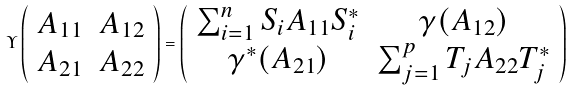Convert formula to latex. <formula><loc_0><loc_0><loc_500><loc_500>\Upsilon \left ( \begin{array} { c c } A _ { 1 1 } & A _ { 1 2 } \\ A _ { 2 1 } & A _ { 2 2 } \end{array} \right ) = \left ( \begin{array} { c c } \sum _ { i = 1 } ^ { n } S _ { i } A _ { 1 1 } S _ { i } ^ { * } & \gamma ( A _ { 1 2 } ) \\ \gamma ^ { * } ( A _ { 2 1 } ) & \sum _ { j = 1 } ^ { p } T _ { j } A _ { 2 2 } T _ { j } ^ { * } \end{array} \right )</formula> 